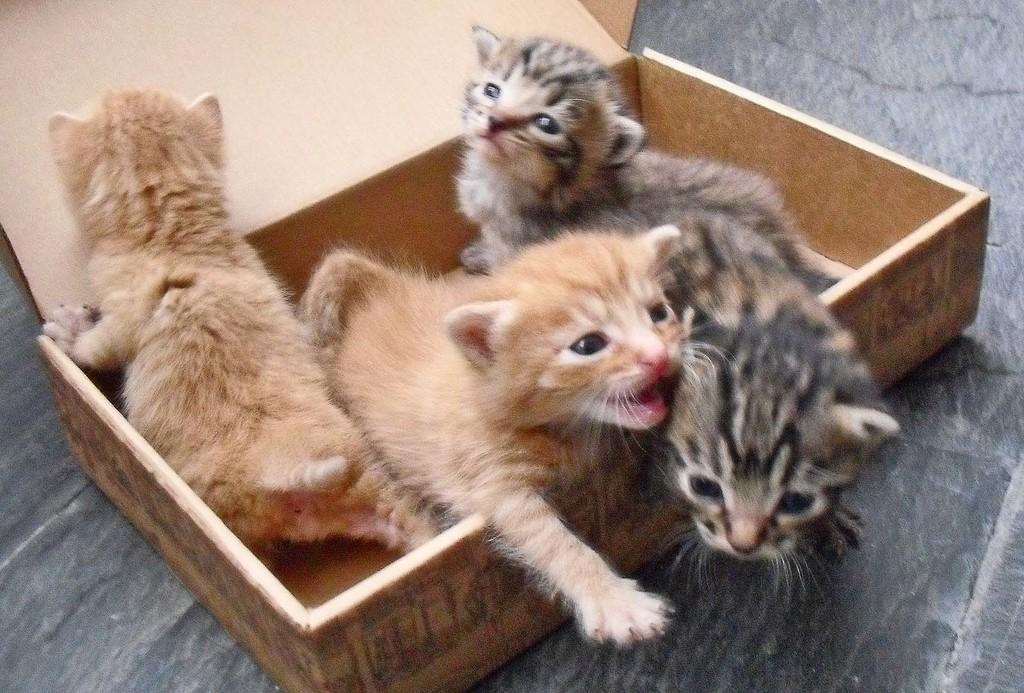Could you give a brief overview of what you see in this image? In this picture, we see the four kittens are placed in the wooden box. At the top, we see the wooden planks or a box. At the bottom, we see the floor. 